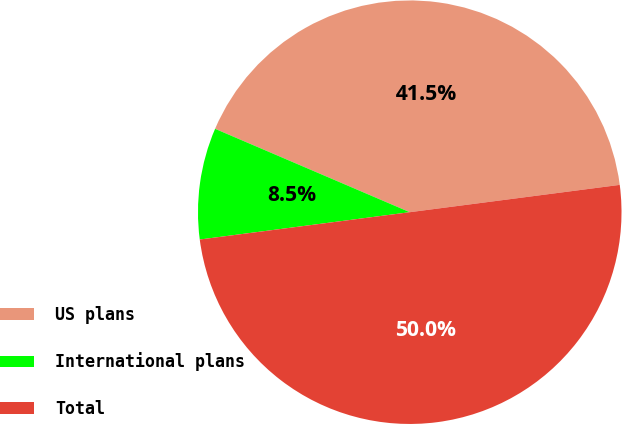Convert chart to OTSL. <chart><loc_0><loc_0><loc_500><loc_500><pie_chart><fcel>US plans<fcel>International plans<fcel>Total<nl><fcel>41.5%<fcel>8.5%<fcel>50.0%<nl></chart> 